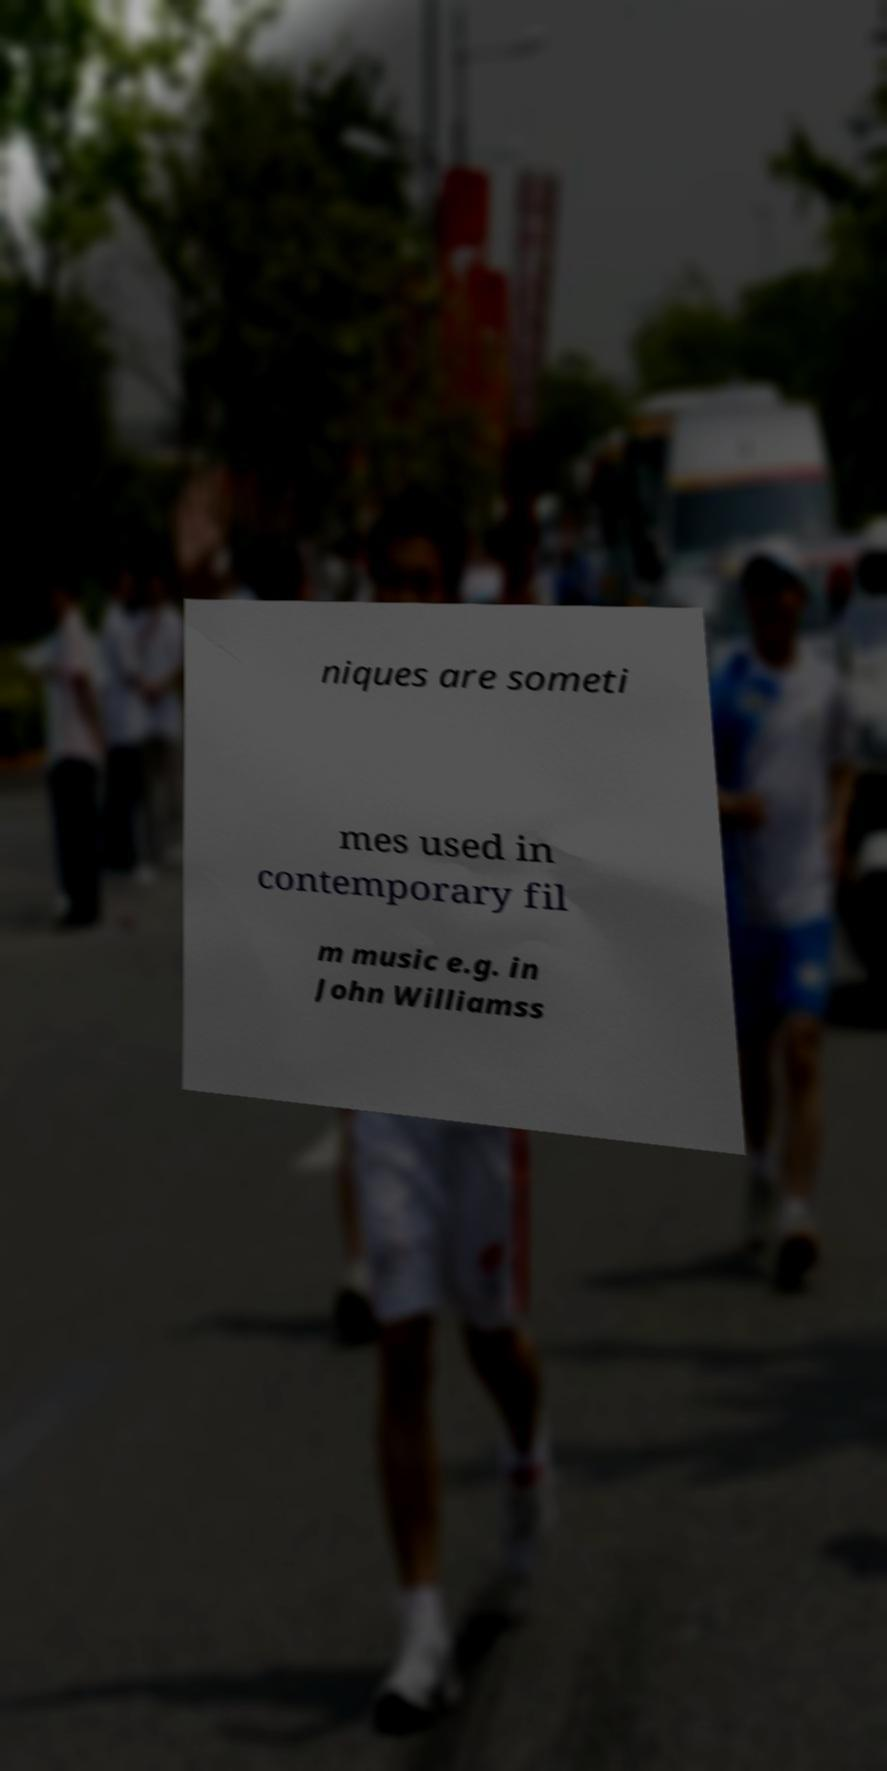Could you assist in decoding the text presented in this image and type it out clearly? niques are someti mes used in contemporary fil m music e.g. in John Williamss 